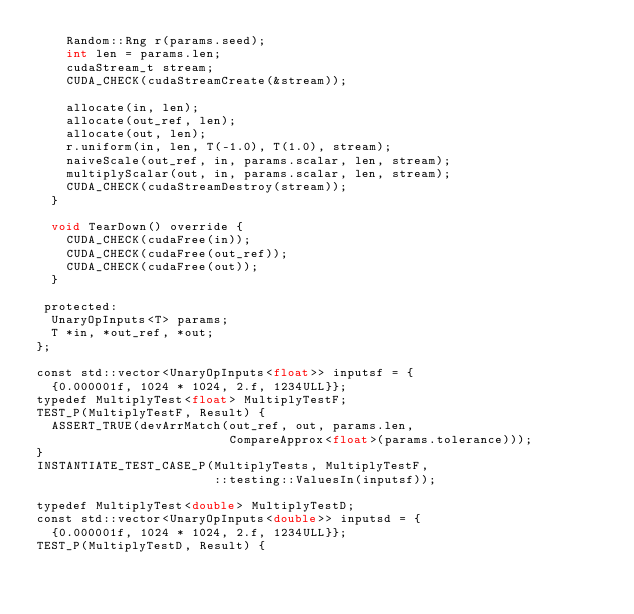<code> <loc_0><loc_0><loc_500><loc_500><_Cuda_>    Random::Rng r(params.seed);
    int len = params.len;
    cudaStream_t stream;
    CUDA_CHECK(cudaStreamCreate(&stream));

    allocate(in, len);
    allocate(out_ref, len);
    allocate(out, len);
    r.uniform(in, len, T(-1.0), T(1.0), stream);
    naiveScale(out_ref, in, params.scalar, len, stream);
    multiplyScalar(out, in, params.scalar, len, stream);
    CUDA_CHECK(cudaStreamDestroy(stream));
  }

  void TearDown() override {
    CUDA_CHECK(cudaFree(in));
    CUDA_CHECK(cudaFree(out_ref));
    CUDA_CHECK(cudaFree(out));
  }

 protected:
  UnaryOpInputs<T> params;
  T *in, *out_ref, *out;
};

const std::vector<UnaryOpInputs<float>> inputsf = {
  {0.000001f, 1024 * 1024, 2.f, 1234ULL}};
typedef MultiplyTest<float> MultiplyTestF;
TEST_P(MultiplyTestF, Result) {
  ASSERT_TRUE(devArrMatch(out_ref, out, params.len,
                          CompareApprox<float>(params.tolerance)));
}
INSTANTIATE_TEST_CASE_P(MultiplyTests, MultiplyTestF,
                        ::testing::ValuesIn(inputsf));

typedef MultiplyTest<double> MultiplyTestD;
const std::vector<UnaryOpInputs<double>> inputsd = {
  {0.000001f, 1024 * 1024, 2.f, 1234ULL}};
TEST_P(MultiplyTestD, Result) {</code> 